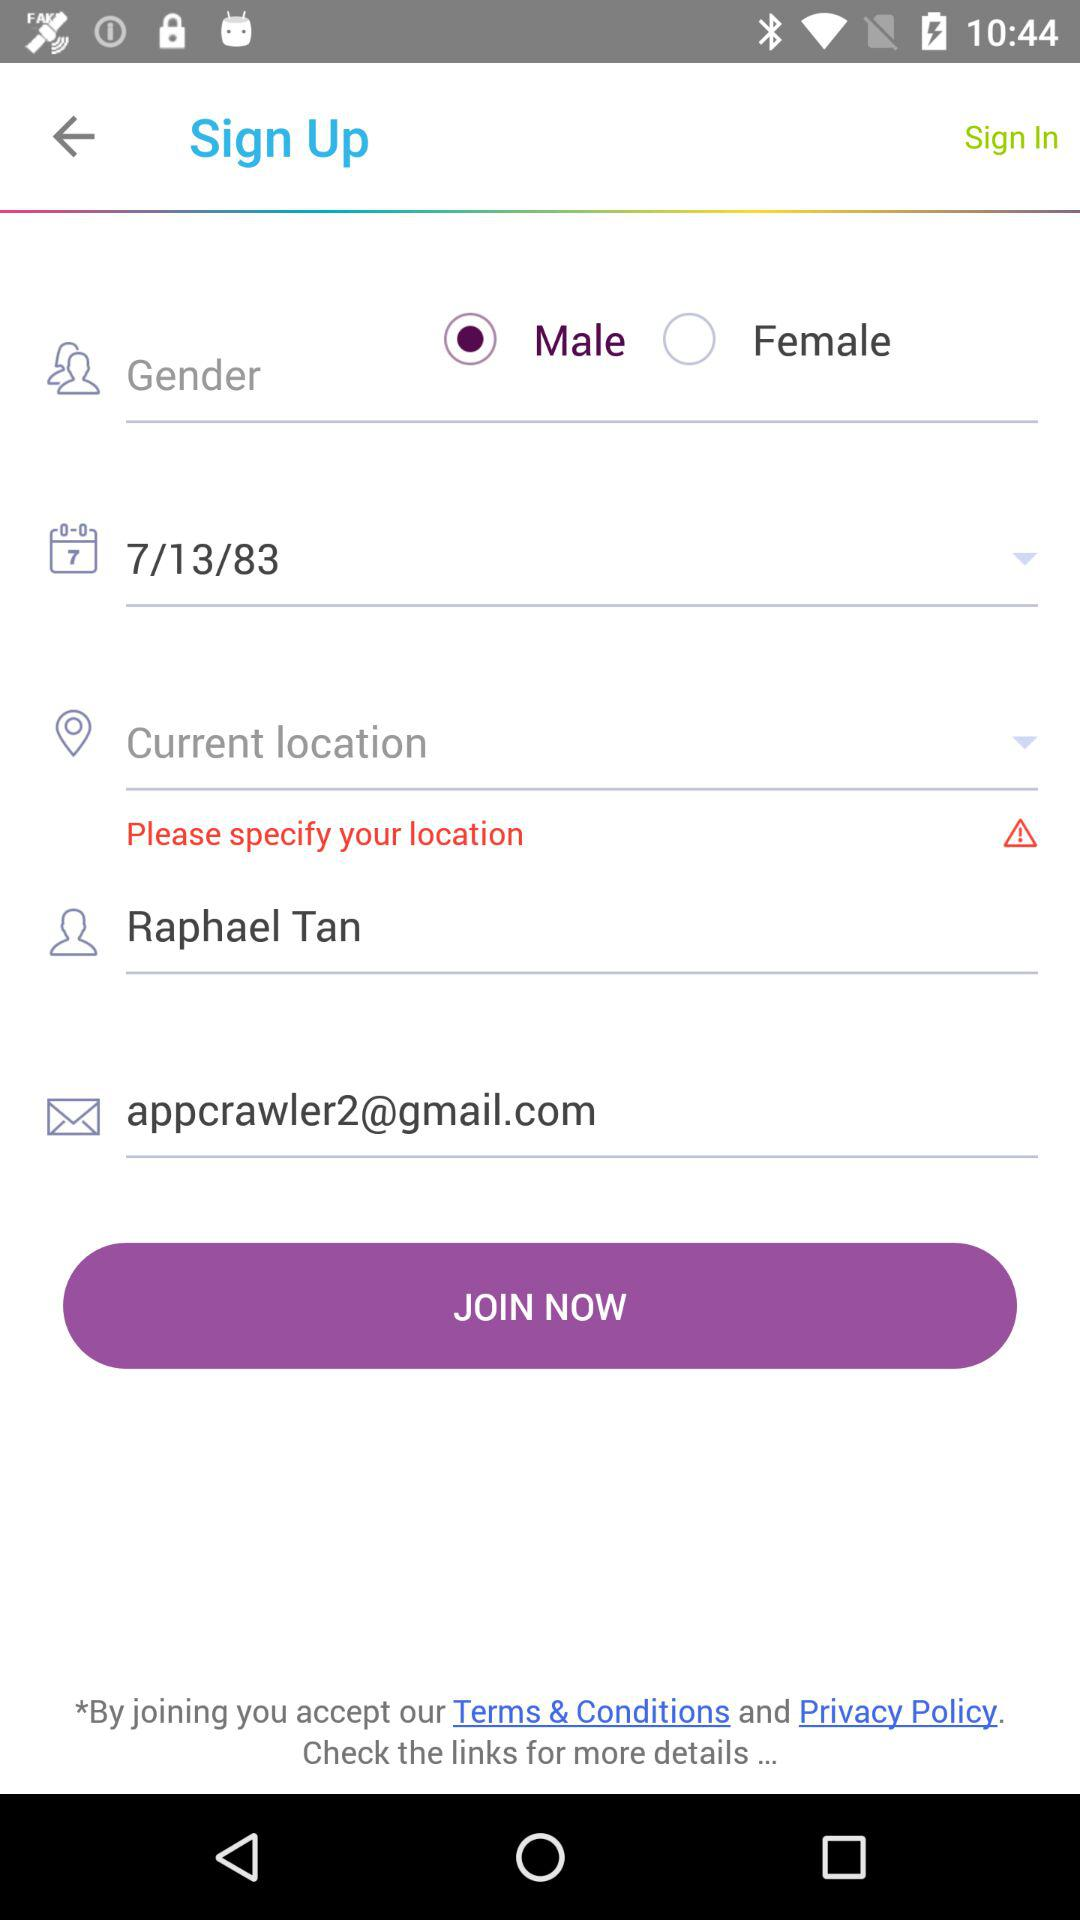What is the name of the user? The name of the user is Raphael Tan. 